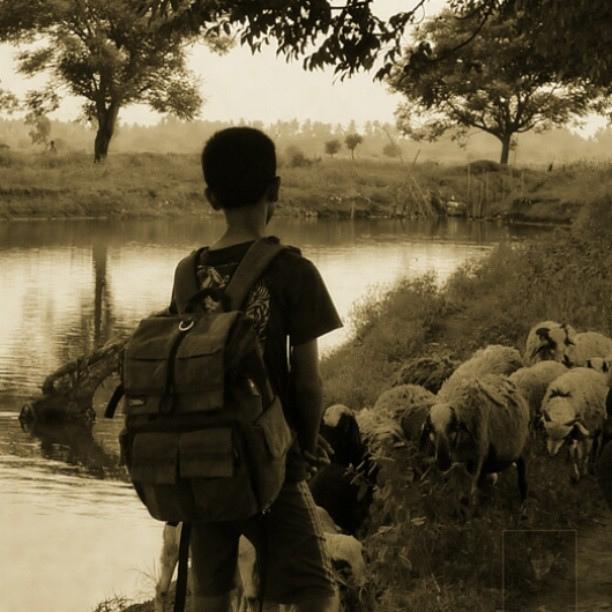What is the boy wearing?
Write a very short answer. Backpack. How many sheep are there?
Concise answer only. 8. What are the sheep doing?
Quick response, please. Walking. 